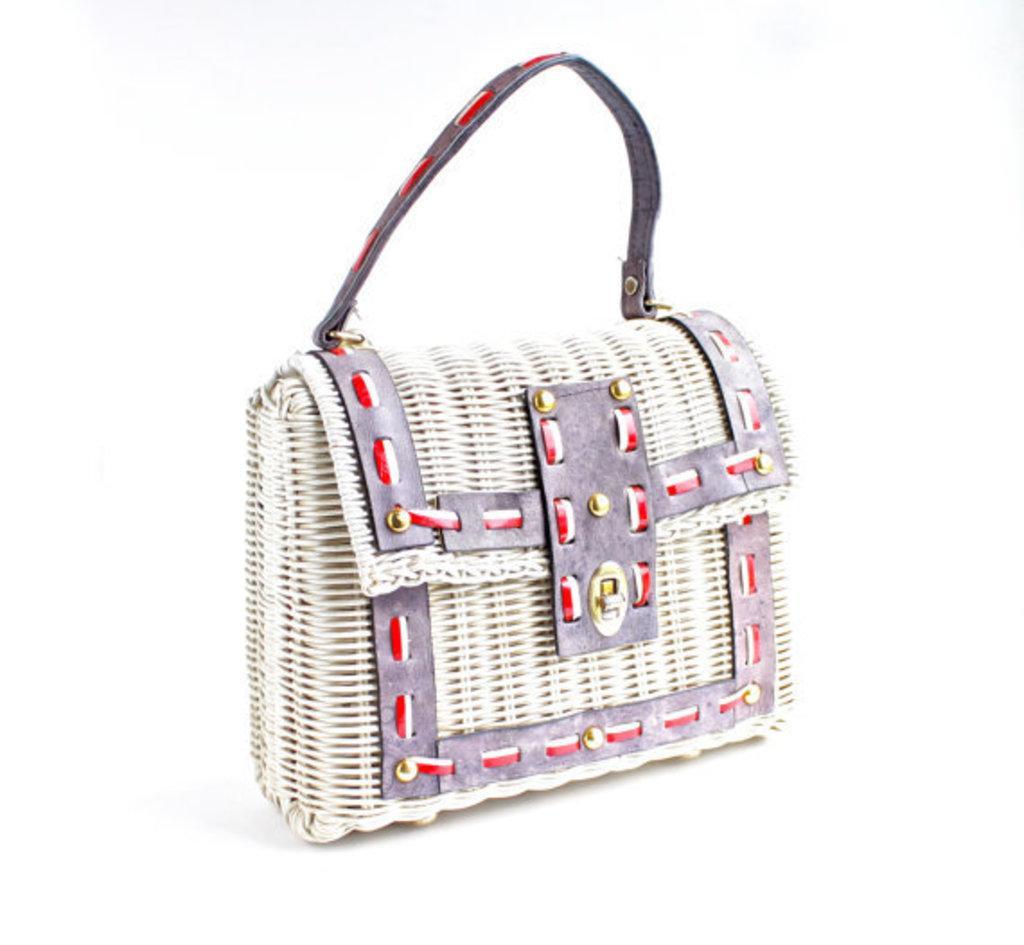Describe this image in one or two sentences. This picture seems to be of inside. In the foreground there is a purse placed on the surface and the background is white in color. 